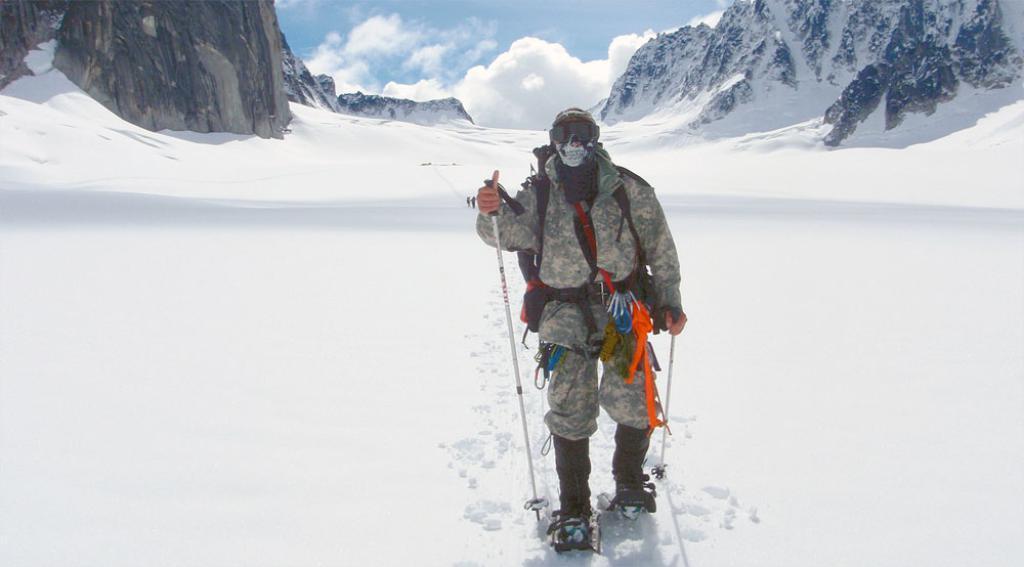In one or two sentences, can you explain what this image depicts? In this picture I can see there is a man walking, he is wearing glasses, a mask, he is holding ski sticks and there is snow on the floor. There is a mountain at left and right sides. The sky is clear. 